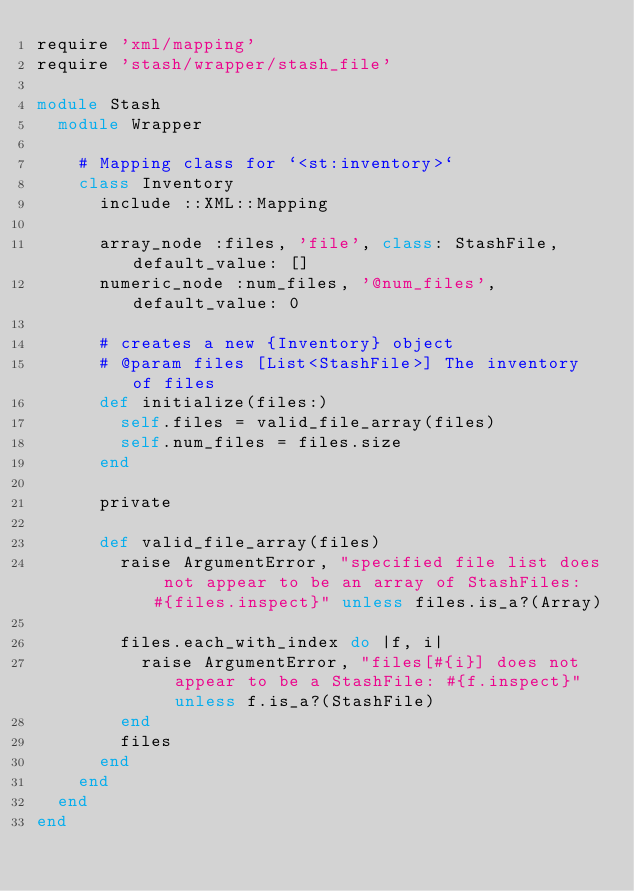Convert code to text. <code><loc_0><loc_0><loc_500><loc_500><_Ruby_>require 'xml/mapping'
require 'stash/wrapper/stash_file'

module Stash
  module Wrapper

    # Mapping class for `<st:inventory>`
    class Inventory
      include ::XML::Mapping

      array_node :files, 'file', class: StashFile, default_value: []
      numeric_node :num_files, '@num_files', default_value: 0

      # creates a new {Inventory} object
      # @param files [List<StashFile>] The inventory of files
      def initialize(files:)
        self.files = valid_file_array(files)
        self.num_files = files.size
      end

      private

      def valid_file_array(files)
        raise ArgumentError, "specified file list does not appear to be an array of StashFiles: #{files.inspect}" unless files.is_a?(Array)

        files.each_with_index do |f, i|
          raise ArgumentError, "files[#{i}] does not appear to be a StashFile: #{f.inspect}" unless f.is_a?(StashFile)
        end
        files
      end
    end
  end
end
</code> 